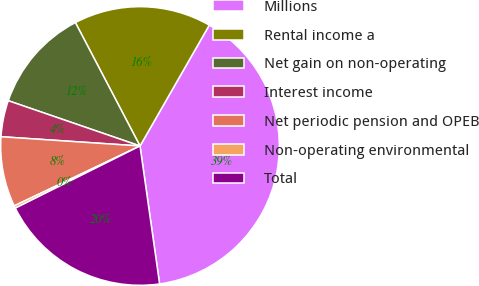<chart> <loc_0><loc_0><loc_500><loc_500><pie_chart><fcel>Millions<fcel>Rental income a<fcel>Net gain on non-operating<fcel>Interest income<fcel>Net periodic pension and OPEB<fcel>Non-operating environmental<fcel>Total<nl><fcel>39.47%<fcel>15.96%<fcel>12.05%<fcel>4.21%<fcel>8.13%<fcel>0.29%<fcel>19.88%<nl></chart> 